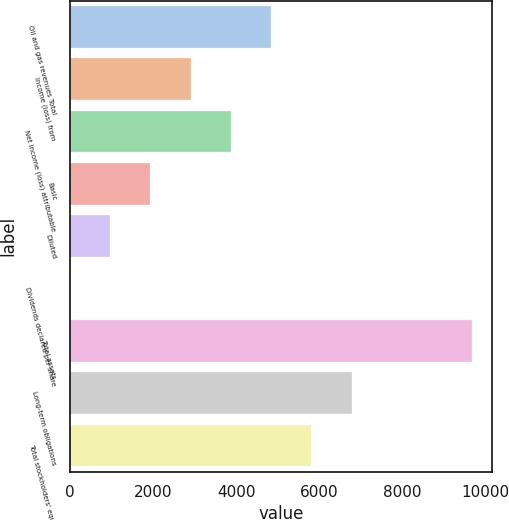<chart> <loc_0><loc_0><loc_500><loc_500><bar_chart><fcel>Oil and gas revenues Total<fcel>Income (loss) from<fcel>Net income (loss) attributable<fcel>Basic<fcel>Diluted<fcel>Dividends declared per share<fcel>Total assets<fcel>Long-term obligations<fcel>Total stockholders' equity<nl><fcel>4839.58<fcel>2903.78<fcel>3871.68<fcel>1935.88<fcel>967.98<fcel>0.08<fcel>9679.1<fcel>6775.38<fcel>5807.48<nl></chart> 